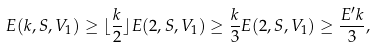<formula> <loc_0><loc_0><loc_500><loc_500>E ( k , S , V _ { 1 } ) \geq \lfloor \frac { k } { 2 } \rfloor E ( 2 , S , V _ { 1 } ) \geq \frac { k } { 3 } E ( 2 , S , V _ { 1 } ) \geq \frac { E ^ { \prime } k } { 3 } ,</formula> 